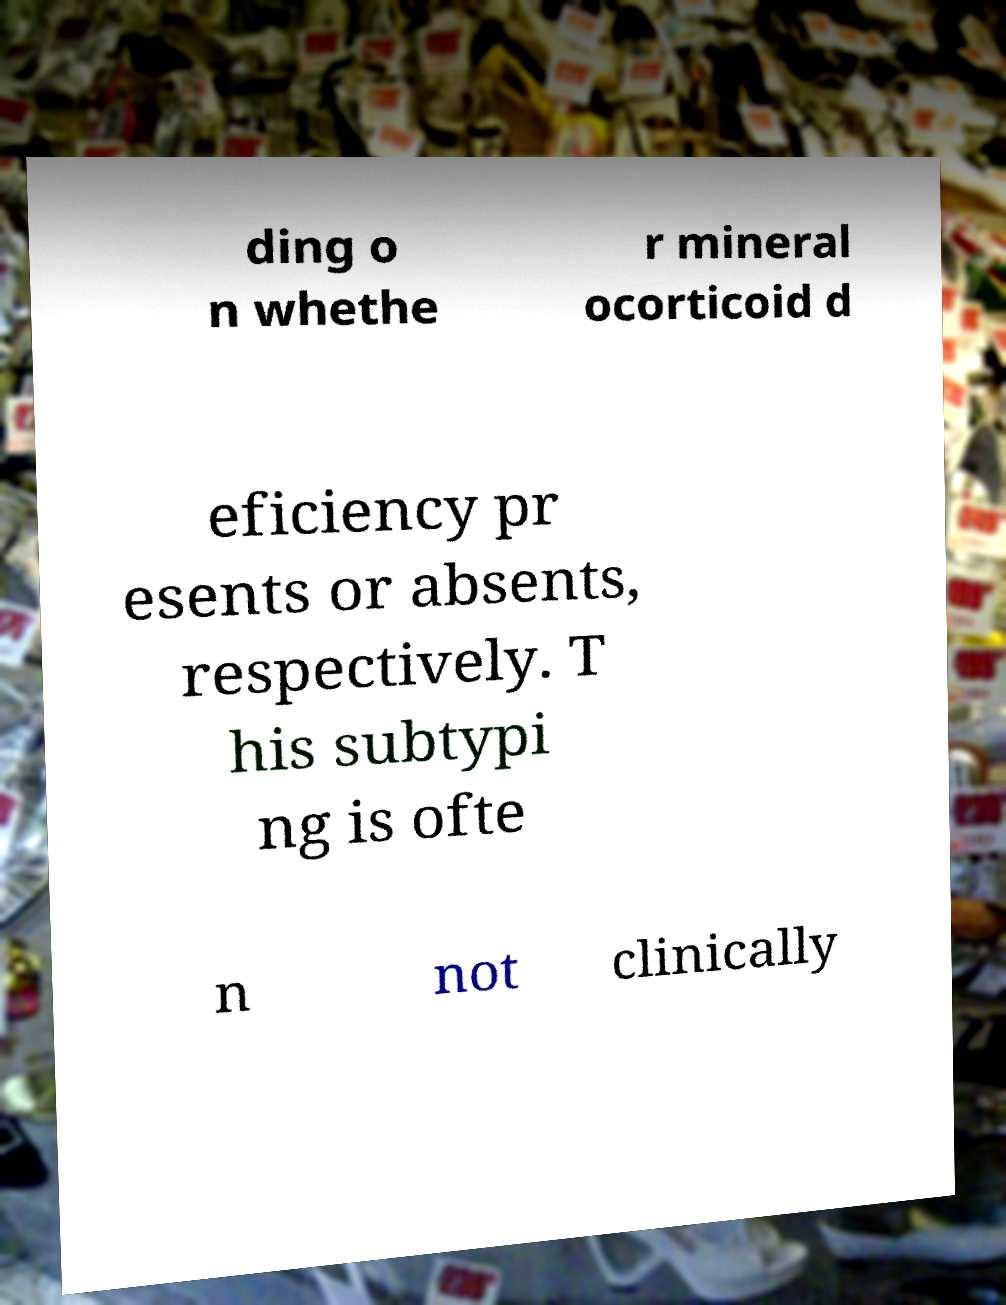Please identify and transcribe the text found in this image. ding o n whethe r mineral ocorticoid d eficiency pr esents or absents, respectively. T his subtypi ng is ofte n not clinically 